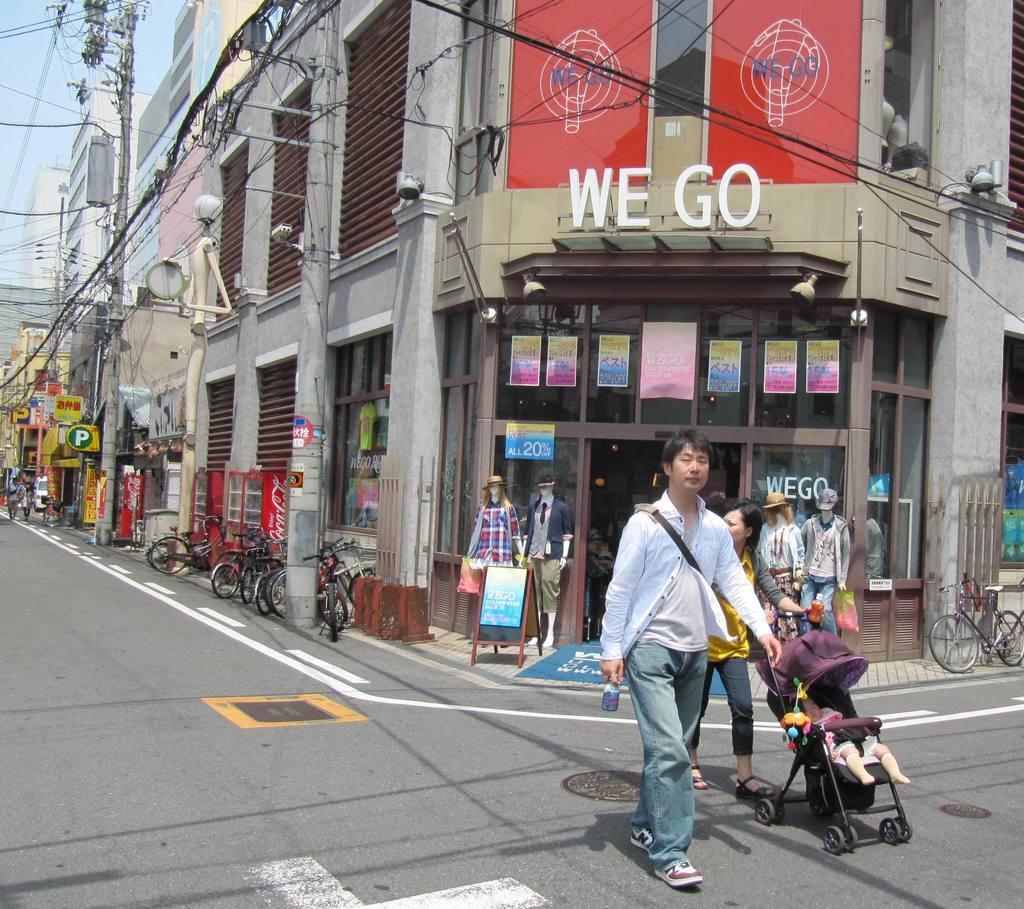Describe this image in one or two sentences. This picture is clicked outside. On the right we can see a person wearing white color shirt, holding an object and walking on the ground and we can see another person and we can see a baby in the stroller and we can see the mannequins wearing clothes and we can see the bicycles, text on the banners and we can see the buildings, cables and many other objects. In the background we can see sky, poles, cables and some other objects. 